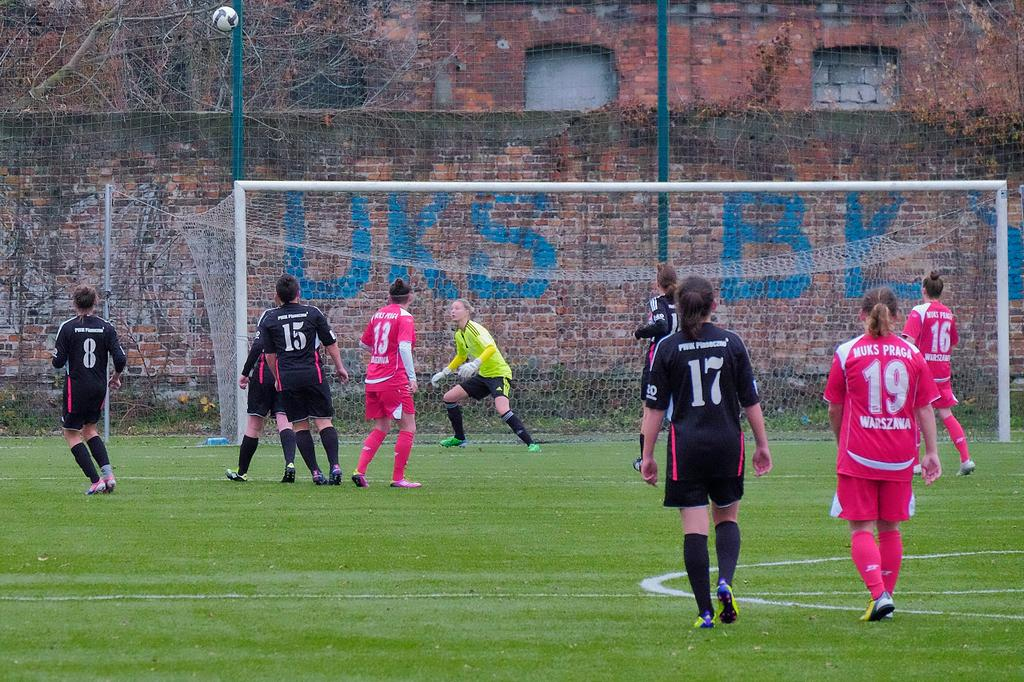Provide a one-sentence caption for the provided image. some men playing football, one of whom has a number 17 on his shirt. 